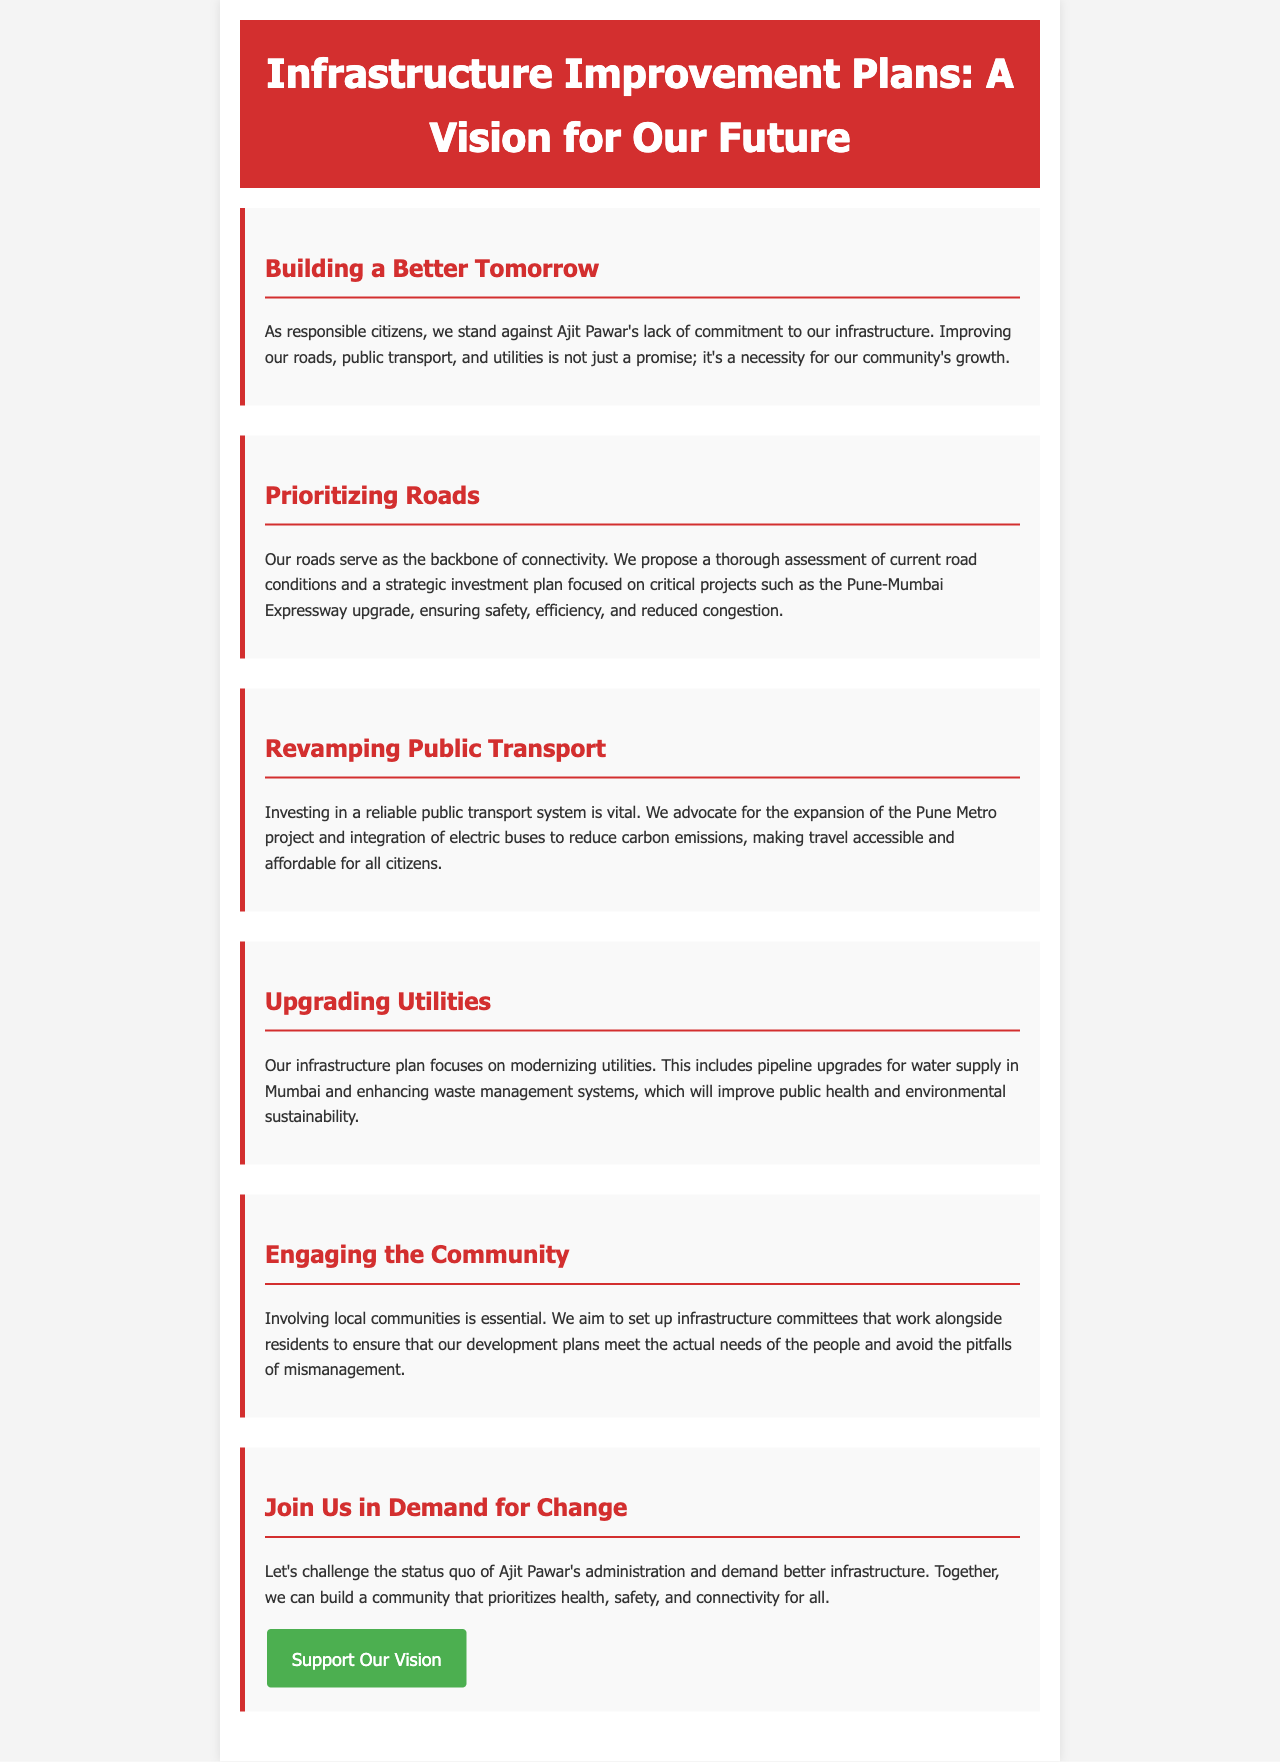What is the title of the document? The title of the document is the main heading, which summarizes the content.
Answer: Infrastructure Improvement Plans: A Vision for Our Future Who is the target of criticism in this brochure? The document explicitly mentions the individual whose policies are being challenged, indicating the focus of the critique.
Answer: Ajit Pawar What is the proposed infrastructure project mentioned for roads? The document specifies a critical project aimed at improving roads, highlighting its significance.
Answer: Pune-Mumbai Expressway upgrade Which public transport project is advocated for expansion? The text identifies a specific public transport initiative that is emphasized for investment and expansion.
Answer: Pune Metro project What is one method proposed to improve waste management? The brochure discusses upgrading utilities, specifically mentioning an aspect of waste management that will be enhanced.
Answer: Enhancing waste management systems Why is community engagement emphasized? The document states the importance of including local residents in planning, suggesting a deeper rationale behind this aim.
Answer: To ensure development plans meet actual needs What color is used in the header of the brochure? The background color of the header is mentioned in the design section, giving an attribute of the document’s formatting.
Answer: Red What is the call to action in the brochure? The document concludes with a specific call to action for readers, inviting them to take a particular step.
Answer: Support Our Vision 